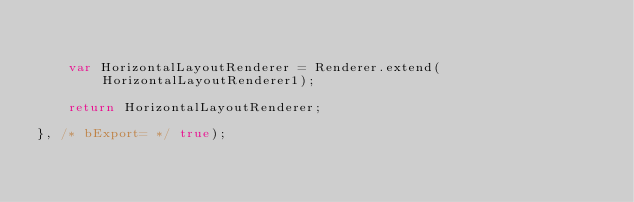<code> <loc_0><loc_0><loc_500><loc_500><_JavaScript_>

	var HorizontalLayoutRenderer = Renderer.extend(HorizontalLayoutRenderer1);

	return HorizontalLayoutRenderer;

}, /* bExport= */ true);
</code> 